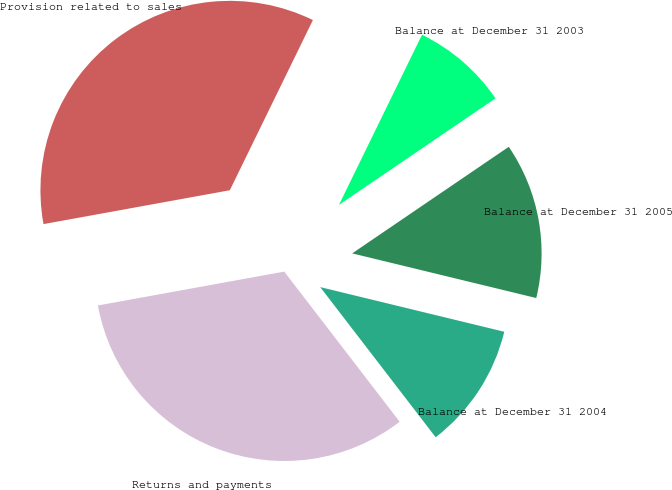<chart> <loc_0><loc_0><loc_500><loc_500><pie_chart><fcel>Balance at December 31 2003<fcel>Provision related to sales<fcel>Returns and payments<fcel>Balance at December 31 2004<fcel>Balance at December 31 2005<nl><fcel>8.26%<fcel>35.09%<fcel>32.57%<fcel>10.78%<fcel>13.3%<nl></chart> 